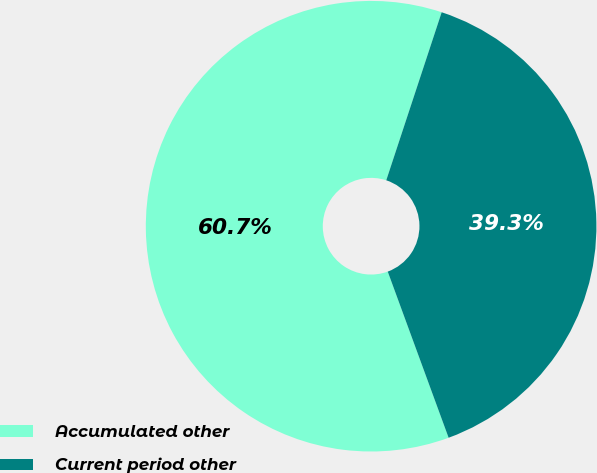Convert chart. <chart><loc_0><loc_0><loc_500><loc_500><pie_chart><fcel>Accumulated other<fcel>Current period other<nl><fcel>60.66%<fcel>39.34%<nl></chart> 